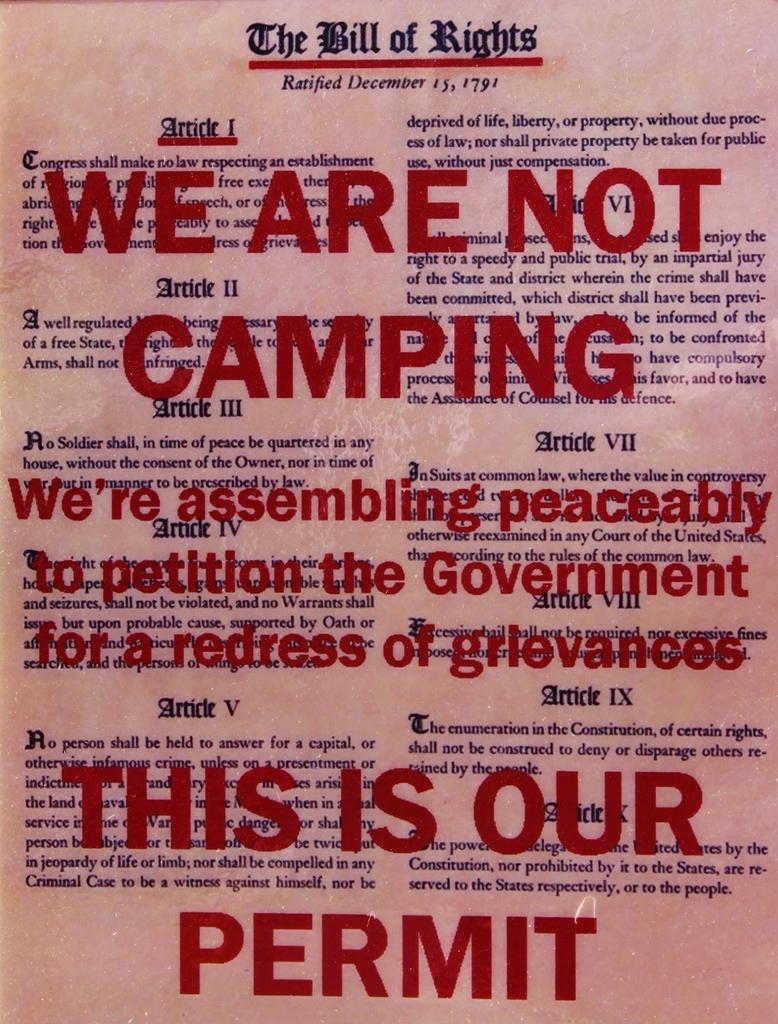What types of items can be seen in the image? There are different articles in the image. Can you describe any specific feature of the text in the image? There are words with red color in the image. How many feet are visible in the image? There are no feet present in the image. What is the wind doing to the articles in the image? There is no wind or blowing action depicted in the image. 